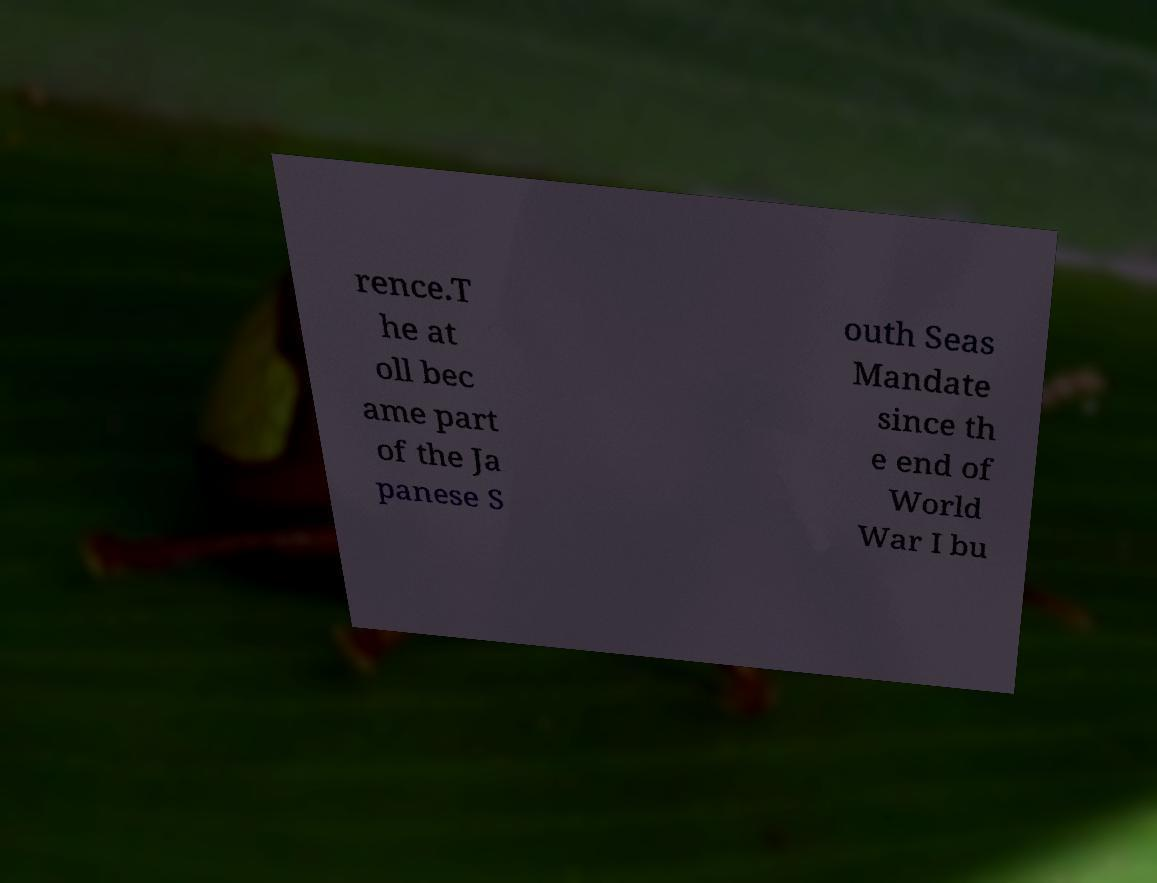What messages or text are displayed in this image? I need them in a readable, typed format. rence.T he at oll bec ame part of the Ja panese S outh Seas Mandate since th e end of World War I bu 